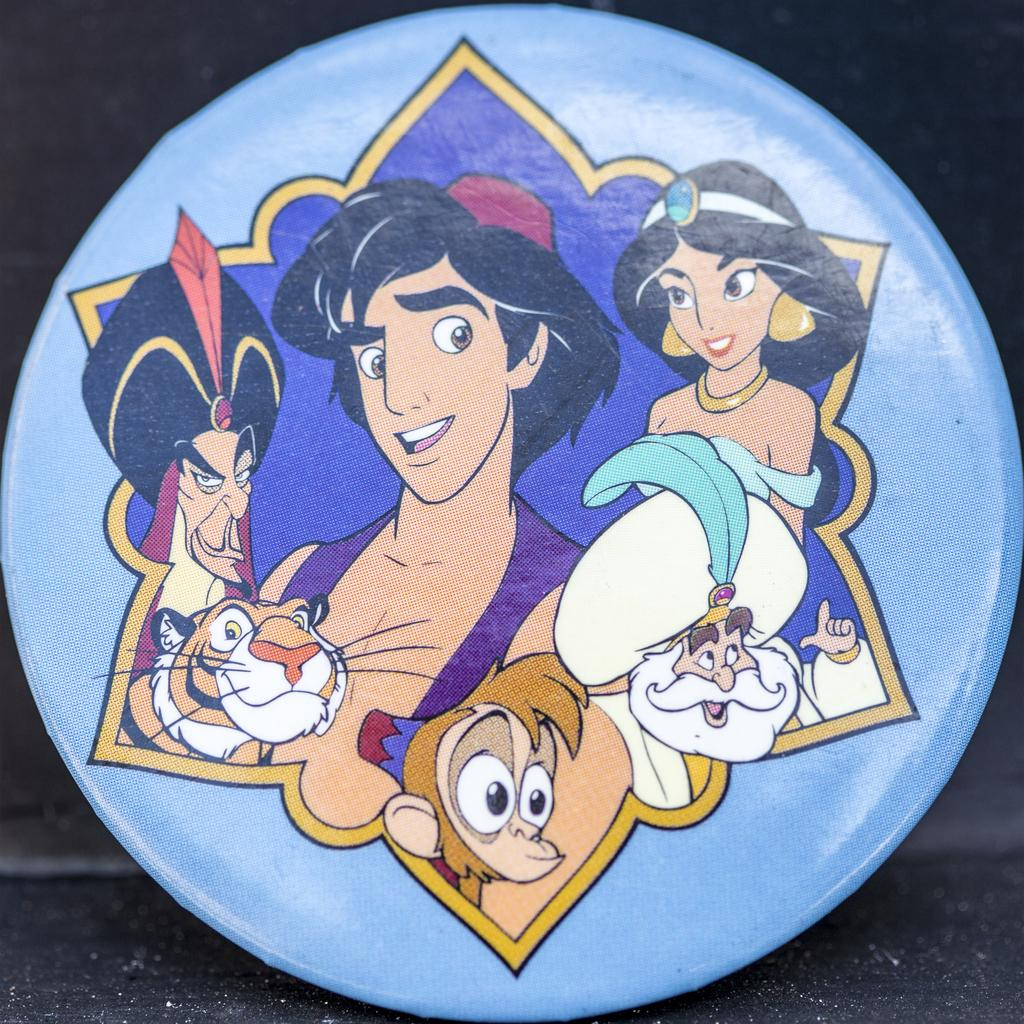What is the primary surface visible in the image? The image contains a floor. Can you describe any objects on the floor? There is a small, circular frame on the floor. What type of content is displayed within the frame? The frame contains cartoon pictures. How does the process of making jam relate to the image? The image does not depict any process related to making jam, nor does it contain any references to jam. 